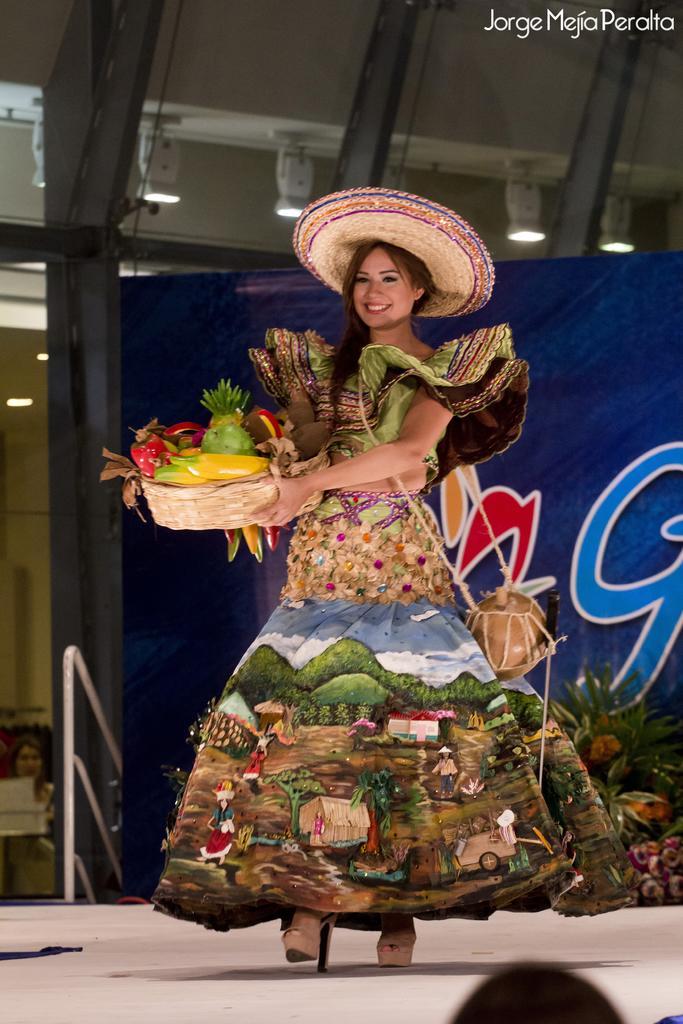In one or two sentences, can you explain what this image depicts? In the center of the image we can see a lady is walking on the stage and wearing a costume, hat, bag and holding a container which contains the plastic fruits. In the background of the image we can see a banner, pillar, wall, rods and some people. At the top of the image we can see the roof and lights. In the top right corner we can see the text. 